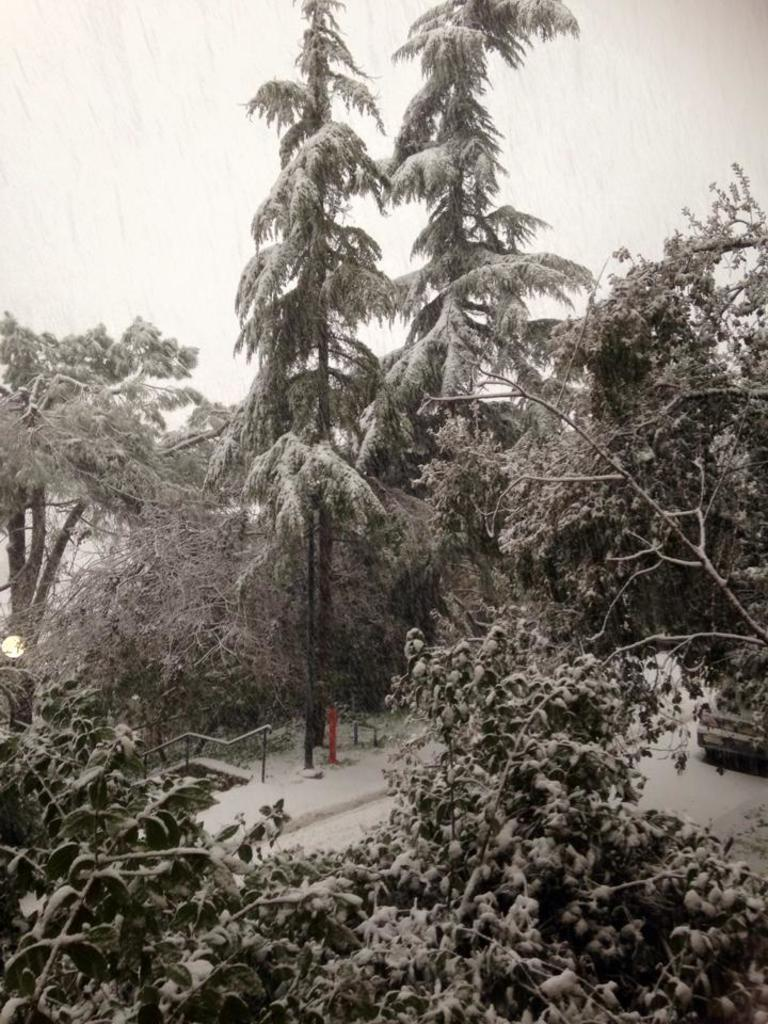What type of natural elements can be seen in the image? There are trees in the image. What else can be seen on the ground in the image? There are objects on the ground in the image. How would you describe the color scheme of the image? The image is black and white in color. What type of office can be seen in the image? There is no office present in the image; it features trees and objects on the ground in a black and white color scheme. 